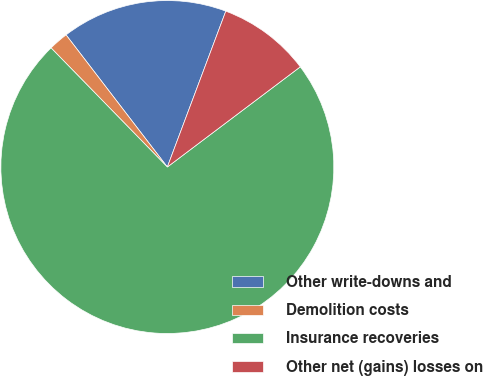<chart> <loc_0><loc_0><loc_500><loc_500><pie_chart><fcel>Other write-downs and<fcel>Demolition costs<fcel>Insurance recoveries<fcel>Other net (gains) losses on<nl><fcel>16.12%<fcel>1.9%<fcel>72.97%<fcel>9.01%<nl></chart> 